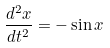Convert formula to latex. <formula><loc_0><loc_0><loc_500><loc_500>\frac { d ^ { 2 } x } { d t ^ { 2 } } = - \sin x</formula> 